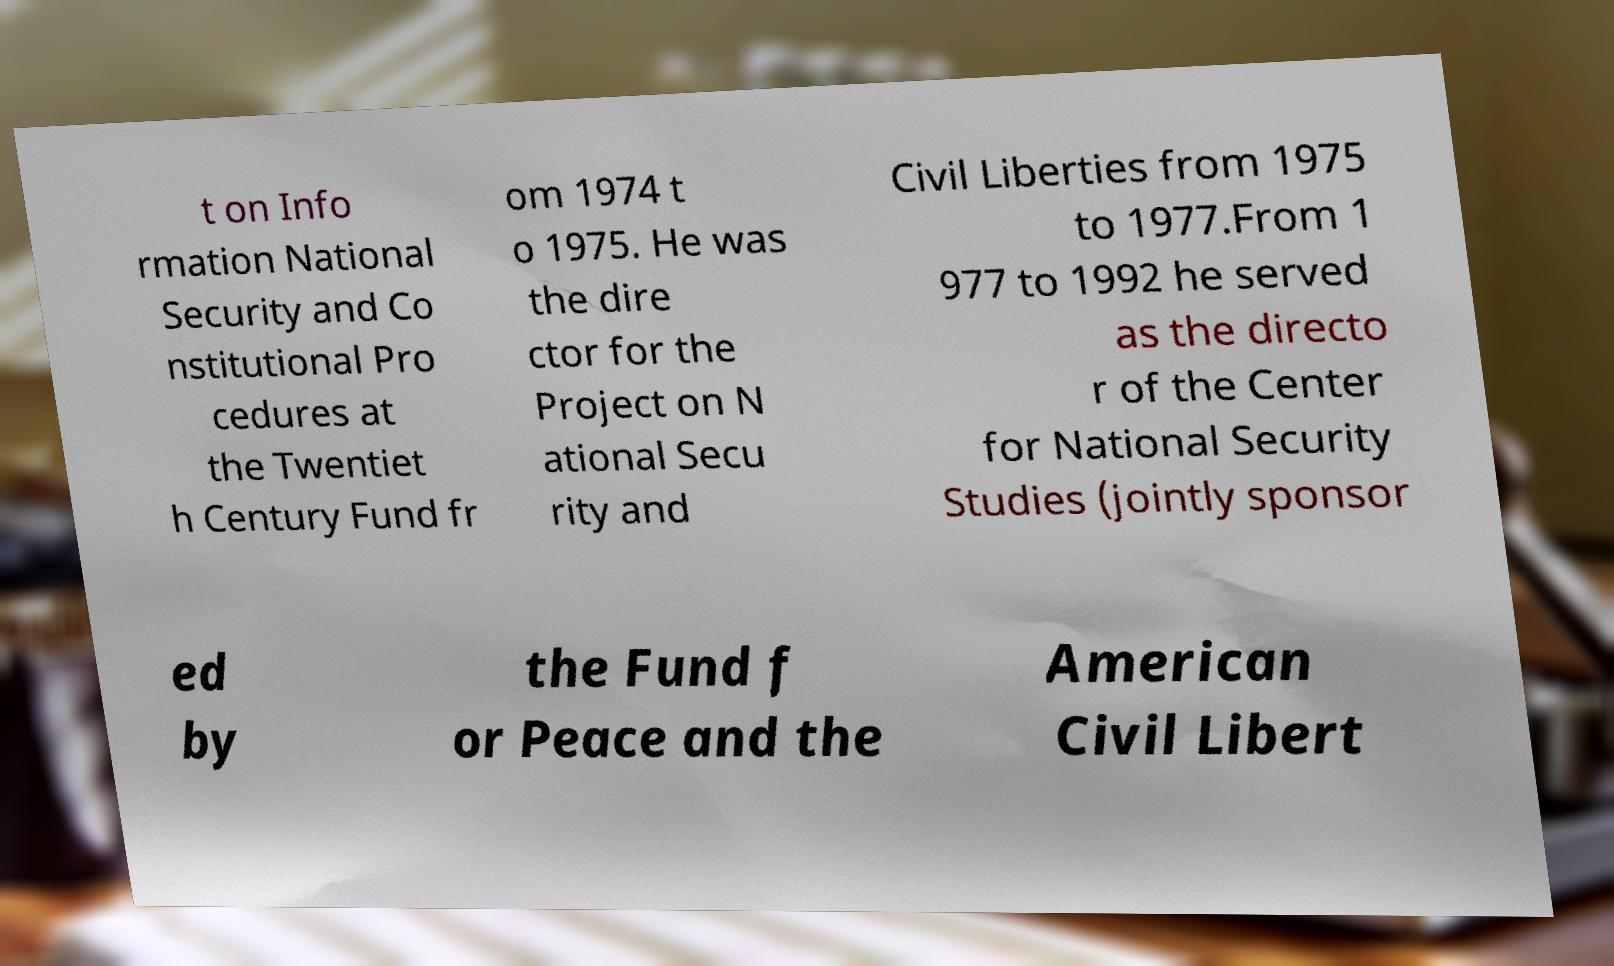For documentation purposes, I need the text within this image transcribed. Could you provide that? t on Info rmation National Security and Co nstitutional Pro cedures at the Twentiet h Century Fund fr om 1974 t o 1975. He was the dire ctor for the Project on N ational Secu rity and Civil Liberties from 1975 to 1977.From 1 977 to 1992 he served as the directo r of the Center for National Security Studies (jointly sponsor ed by the Fund f or Peace and the American Civil Libert 